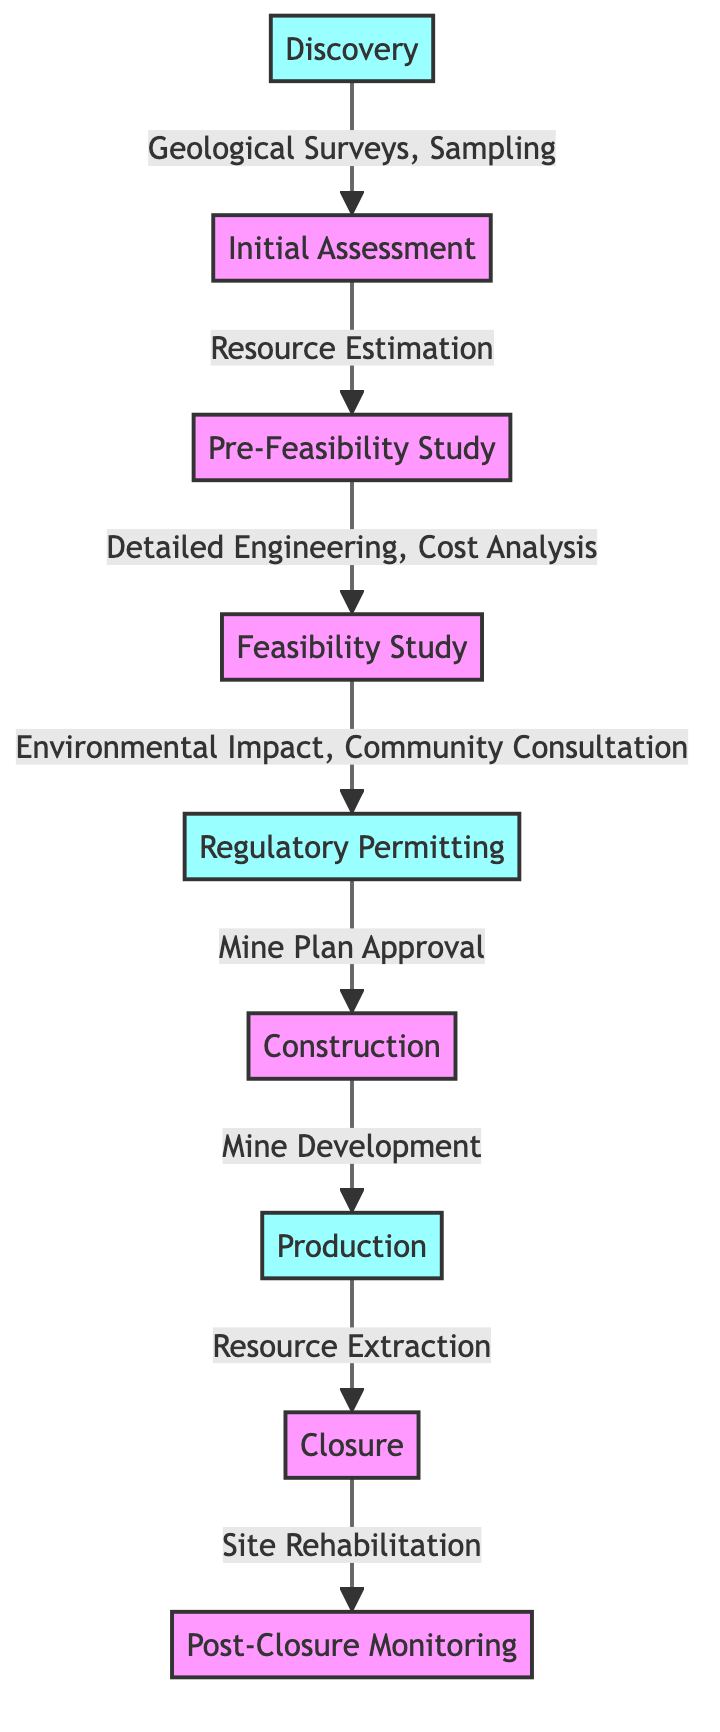What is the first milestone in the diagram? The first milestone shown in the diagram is "Discovery," which is the starting point of the mineral exploration project.
Answer: Discovery How many key milestones are depicted in the diagram? The diagram shows five key milestones, which are "Discovery," "Permitting," "Production," "Closure," and "Post-Closure Monitoring."
Answer: 5 What is the process that follows the "Feasibility Study"? After the "Feasibility Study," the next step in the process is "Regulatory Permitting." This indicates that regulatory approval is required following the feasibility assessment.
Answer: Regulatory Permitting Which stage involves "Mine Plan Approval"? The stage that involves "Mine Plan Approval" is "Regulatory Permitting." This specifies that before construction can begin, the mine plan needs to be approved.
Answer: Regulatory Permitting What follows the "Closure" stage in the lifecycle of the project? Following the "Closure" stage, the next stage is "Post-Closure Monitoring," which suggests ongoing observations and evaluations after the mine is closed.
Answer: Post-Closure Monitoring What type of analysis is performed during the "Pre-Feasibility Study"? During the "Pre-Feasibility Study," "Detailed Engineering, Cost Analysis" is performed, which highlights the necessary evaluations before moving to the feasibility stage.
Answer: Detailed Engineering, Cost Analysis Which two stages are linked directly by "Resource Extraction"? The stages linked directly by "Resource Extraction" are "Production" and "Closure." This connection shows the movement from extracting resources to the closure of the mining operation.
Answer: Production and Closure At which stage is "Environmental Impact" evaluated? "Environmental Impact" is evaluated during the "Feasibility Study," indicating that environmental considerations are part of the assessment before regulatory permitting.
Answer: Feasibility Study What step comes before "Post-Closure Monitoring"? The step that comes before "Post-Closure Monitoring" is "Closure," indicating that monitoring occurs after the rehabilitation of the site.
Answer: Closure 